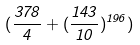<formula> <loc_0><loc_0><loc_500><loc_500>( \frac { 3 7 8 } { 4 } + ( \frac { 1 4 3 } { 1 0 } ) ^ { 1 9 6 } )</formula> 